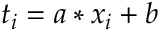Convert formula to latex. <formula><loc_0><loc_0><loc_500><loc_500>t _ { i } = a * x _ { i } + b</formula> 